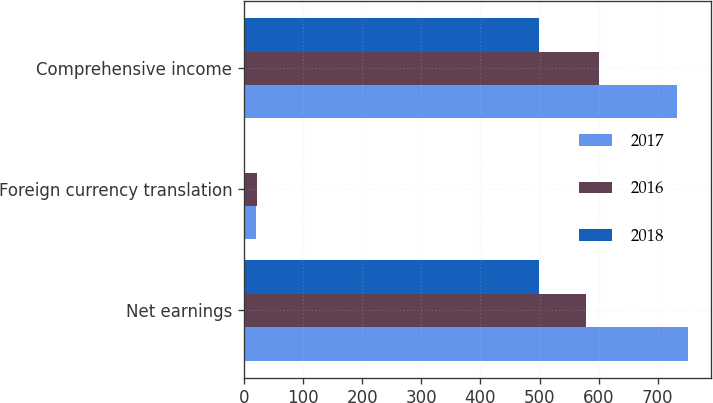<chart> <loc_0><loc_0><loc_500><loc_500><stacked_bar_chart><ecel><fcel>Net earnings<fcel>Foreign currency translation<fcel>Comprehensive income<nl><fcel>2017<fcel>751.9<fcel>19.7<fcel>732.2<nl><fcel>2016<fcel>578.6<fcel>22.2<fcel>600.8<nl><fcel>2018<fcel>499.4<fcel>0.9<fcel>498.5<nl></chart> 